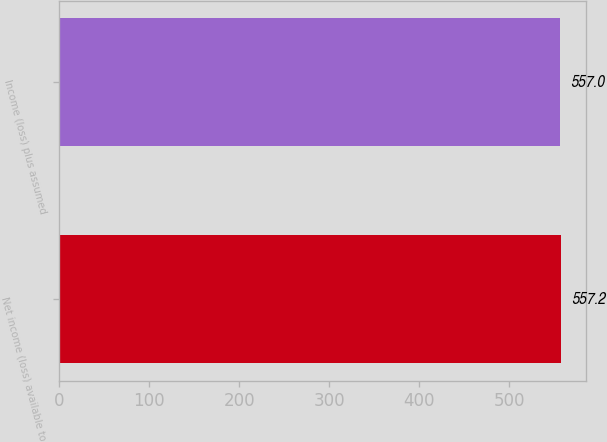<chart> <loc_0><loc_0><loc_500><loc_500><bar_chart><fcel>Net income (loss) available to<fcel>Income (loss) plus assumed<nl><fcel>557.2<fcel>557<nl></chart> 